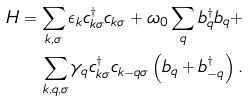Convert formula to latex. <formula><loc_0><loc_0><loc_500><loc_500>H = \sum _ { { k } , \sigma } \epsilon _ { k } c ^ { \dagger } _ { { k } \sigma } c _ { { k } \sigma } + \omega _ { 0 } \sum _ { q } b ^ { \dagger } _ { q } b _ { q } + \\ \sum _ { { k } , { q } , \sigma } \gamma _ { q } c ^ { \dagger } _ { { k } \sigma } c _ { { k } - { q } \sigma } \left ( b _ { q } + b ^ { \dagger } _ { - { q } } \right ) .</formula> 